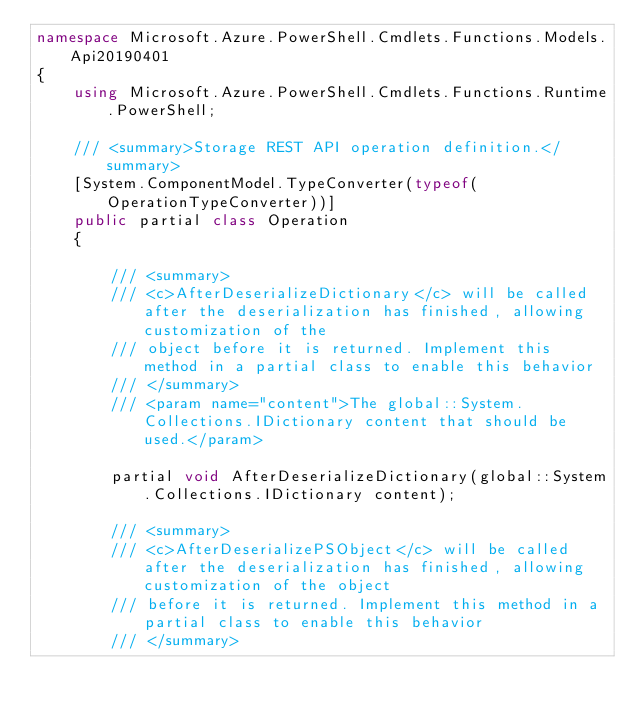Convert code to text. <code><loc_0><loc_0><loc_500><loc_500><_C#_>namespace Microsoft.Azure.PowerShell.Cmdlets.Functions.Models.Api20190401
{
    using Microsoft.Azure.PowerShell.Cmdlets.Functions.Runtime.PowerShell;

    /// <summary>Storage REST API operation definition.</summary>
    [System.ComponentModel.TypeConverter(typeof(OperationTypeConverter))]
    public partial class Operation
    {

        /// <summary>
        /// <c>AfterDeserializeDictionary</c> will be called after the deserialization has finished, allowing customization of the
        /// object before it is returned. Implement this method in a partial class to enable this behavior
        /// </summary>
        /// <param name="content">The global::System.Collections.IDictionary content that should be used.</param>

        partial void AfterDeserializeDictionary(global::System.Collections.IDictionary content);

        /// <summary>
        /// <c>AfterDeserializePSObject</c> will be called after the deserialization has finished, allowing customization of the object
        /// before it is returned. Implement this method in a partial class to enable this behavior
        /// </summary></code> 